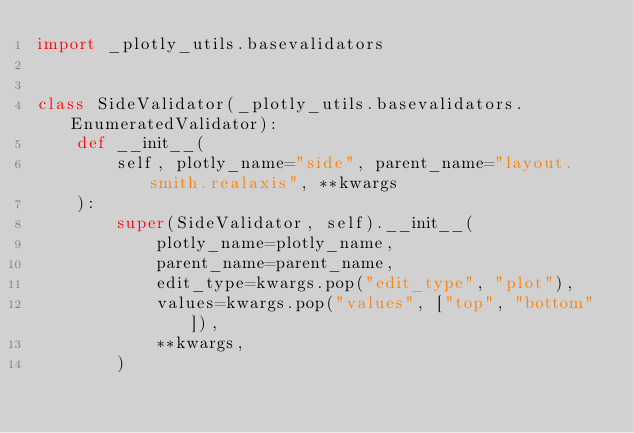<code> <loc_0><loc_0><loc_500><loc_500><_Python_>import _plotly_utils.basevalidators


class SideValidator(_plotly_utils.basevalidators.EnumeratedValidator):
    def __init__(
        self, plotly_name="side", parent_name="layout.smith.realaxis", **kwargs
    ):
        super(SideValidator, self).__init__(
            plotly_name=plotly_name,
            parent_name=parent_name,
            edit_type=kwargs.pop("edit_type", "plot"),
            values=kwargs.pop("values", ["top", "bottom"]),
            **kwargs,
        )
</code> 